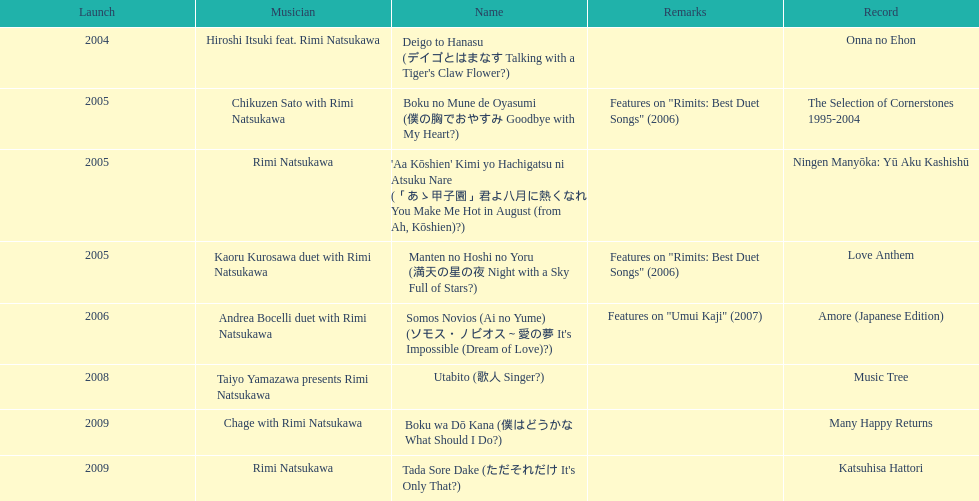What song was this artist on after utabito? Boku wa Dō Kana. 